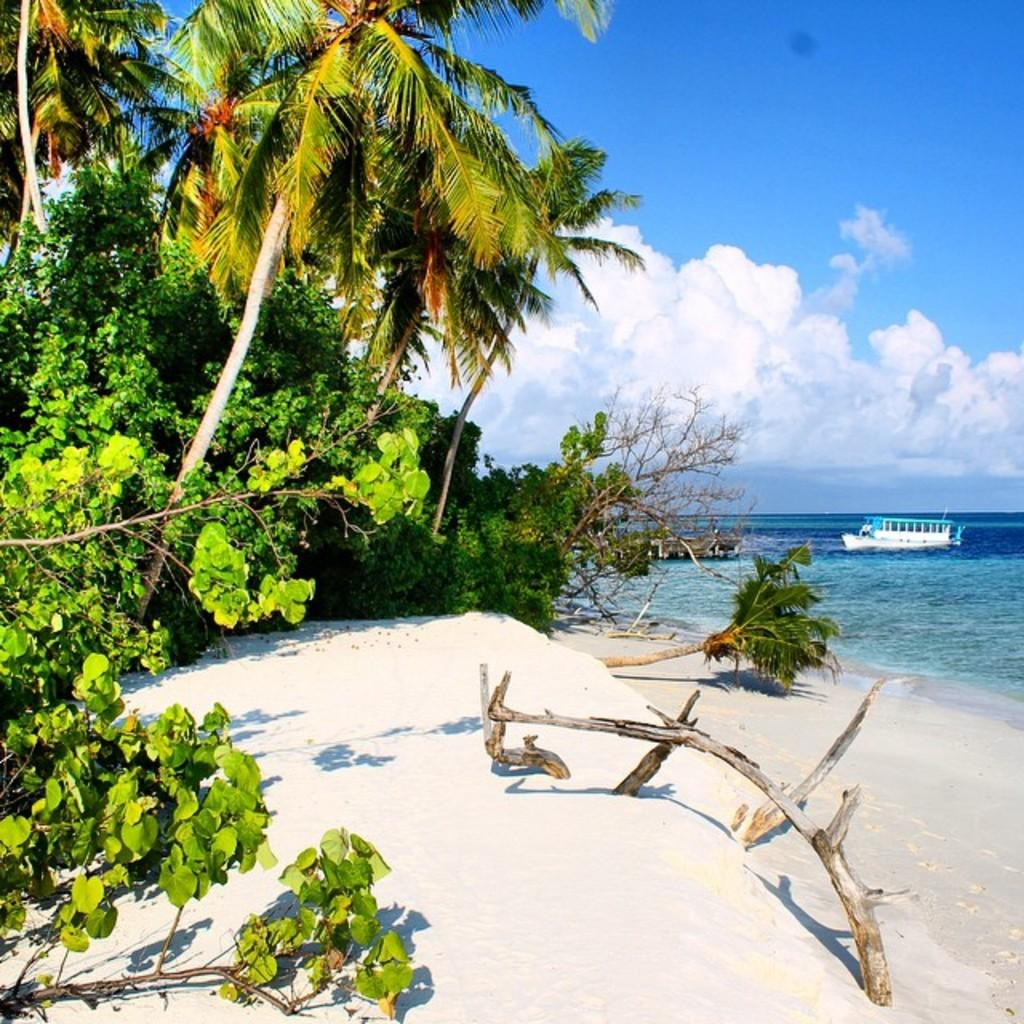What type of terrain is visible in the image? There is sand in the image. What other natural elements can be seen in the image? There are trees in the image. What is on the water in the image? There is a boat on the water in the image. What is visible in the background of the image? The sky is visible in the background of the image. What can be observed in the sky? There are clouds in the sky. What type of songs can be heard coming from the frog in the image? There is no frog present in the image, so it's not possible to determine what, if any, songs might be heard. 